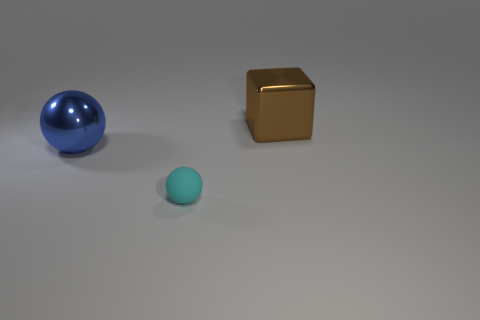Is the number of things greater than the number of big things?
Your answer should be very brief. Yes. Is there a red thing?
Give a very brief answer. No. What number of things are either objects that are behind the cyan matte thing or spheres that are in front of the big blue metal thing?
Make the answer very short. 3. Is the number of brown metallic objects less than the number of small yellow metallic things?
Keep it short and to the point. No. There is a big blue shiny object; are there any large blocks behind it?
Your answer should be very brief. Yes. Do the tiny cyan object and the large sphere have the same material?
Provide a succinct answer. No. There is a large metal thing that is the same shape as the tiny cyan thing; what is its color?
Your answer should be compact. Blue. How many large objects have the same material as the large brown cube?
Offer a very short reply. 1. What number of brown objects are in front of the cyan object?
Give a very brief answer. 0. What is the size of the metal block?
Your response must be concise. Large. 